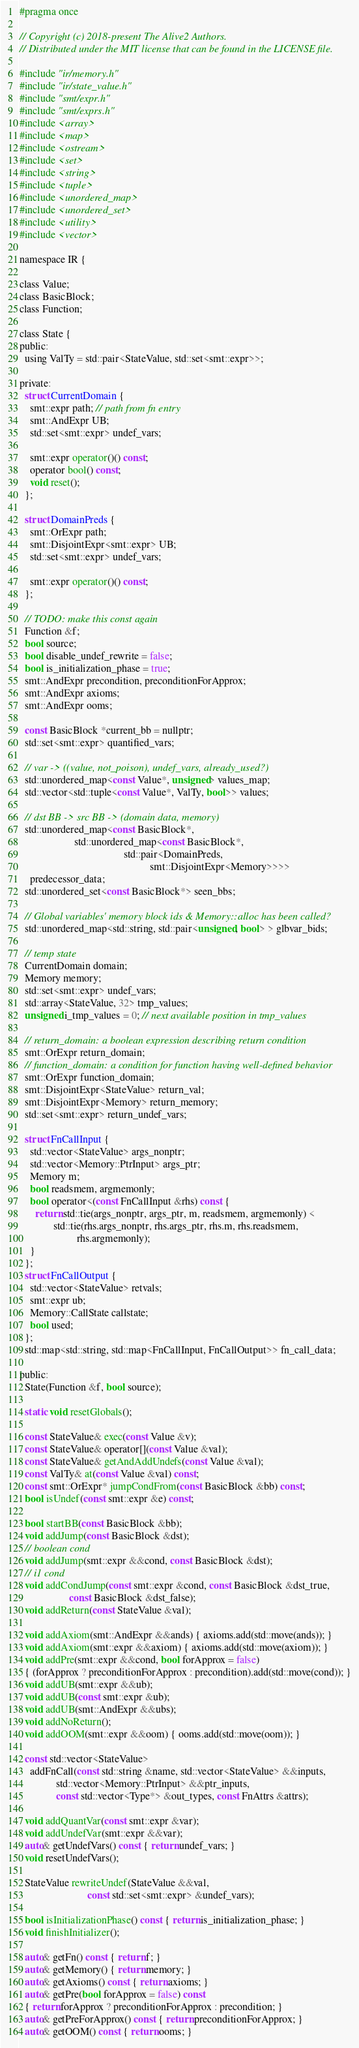Convert code to text. <code><loc_0><loc_0><loc_500><loc_500><_C_>#pragma once

// Copyright (c) 2018-present The Alive2 Authors.
// Distributed under the MIT license that can be found in the LICENSE file.

#include "ir/memory.h"
#include "ir/state_value.h"
#include "smt/expr.h"
#include "smt/exprs.h"
#include <array>
#include <map>
#include <ostream>
#include <set>
#include <string>
#include <tuple>
#include <unordered_map>
#include <unordered_set>
#include <utility>
#include <vector>

namespace IR {

class Value;
class BasicBlock;
class Function;

class State {
public:
  using ValTy = std::pair<StateValue, std::set<smt::expr>>;

private:
  struct CurrentDomain {
    smt::expr path; // path from fn entry
    smt::AndExpr UB;
    std::set<smt::expr> undef_vars;

    smt::expr operator()() const;
    operator bool() const;
    void reset();
  };

  struct DomainPreds {
    smt::OrExpr path;
    smt::DisjointExpr<smt::expr> UB;
    std::set<smt::expr> undef_vars;

    smt::expr operator()() const;
  };

  // TODO: make this const again
  Function &f;
  bool source;
  bool disable_undef_rewrite = false;
  bool is_initialization_phase = true;
  smt::AndExpr precondition, preconditionForApprox;
  smt::AndExpr axioms;
  smt::AndExpr ooms;

  const BasicBlock *current_bb = nullptr;
  std::set<smt::expr> quantified_vars;

  // var -> ((value, not_poison), undef_vars, already_used?)
  std::unordered_map<const Value*, unsigned> values_map;
  std::vector<std::tuple<const Value*, ValTy, bool>> values;

  // dst BB -> src BB -> (domain data, memory)
  std::unordered_map<const BasicBlock*,
                     std::unordered_map<const BasicBlock*,
                                        std::pair<DomainPreds,
                                                  smt::DisjointExpr<Memory>>>>
    predecessor_data;
  std::unordered_set<const BasicBlock*> seen_bbs;

  // Global variables' memory block ids & Memory::alloc has been called?
  std::unordered_map<std::string, std::pair<unsigned, bool> > glbvar_bids;

  // temp state
  CurrentDomain domain;
  Memory memory;
  std::set<smt::expr> undef_vars;
  std::array<StateValue, 32> tmp_values;
  unsigned i_tmp_values = 0; // next available position in tmp_values

  // return_domain: a boolean expression describing return condition
  smt::OrExpr return_domain;
  // function_domain: a condition for function having well-defined behavior
  smt::OrExpr function_domain;
  smt::DisjointExpr<StateValue> return_val;
  smt::DisjointExpr<Memory> return_memory;
  std::set<smt::expr> return_undef_vars;

  struct FnCallInput {
    std::vector<StateValue> args_nonptr;
    std::vector<Memory::PtrInput> args_ptr;
    Memory m;
    bool readsmem, argmemonly;
    bool operator<(const FnCallInput &rhs) const {
      return std::tie(args_nonptr, args_ptr, m, readsmem, argmemonly) <
             std::tie(rhs.args_nonptr, rhs.args_ptr, rhs.m, rhs.readsmem,
                      rhs.argmemonly);
    }
  };
  struct FnCallOutput {
    std::vector<StateValue> retvals;
    smt::expr ub;
    Memory::CallState callstate;
    bool used;
  };
  std::map<std::string, std::map<FnCallInput, FnCallOutput>> fn_call_data;

public:
  State(Function &f, bool source);

  static void resetGlobals();

  const StateValue& exec(const Value &v);
  const StateValue& operator[](const Value &val);
  const StateValue& getAndAddUndefs(const Value &val);
  const ValTy& at(const Value &val) const;
  const smt::OrExpr* jumpCondFrom(const BasicBlock &bb) const;
  bool isUndef(const smt::expr &e) const;

  bool startBB(const BasicBlock &bb);
  void addJump(const BasicBlock &dst);
  // boolean cond
  void addJump(smt::expr &&cond, const BasicBlock &dst);
  // i1 cond
  void addCondJump(const smt::expr &cond, const BasicBlock &dst_true,
                   const BasicBlock &dst_false);
  void addReturn(const StateValue &val);

  void addAxiom(smt::AndExpr &&ands) { axioms.add(std::move(ands)); }
  void addAxiom(smt::expr &&axiom) { axioms.add(std::move(axiom)); }
  void addPre(smt::expr &&cond, bool forApprox = false)
  { (forApprox ? preconditionForApprox : precondition).add(std::move(cond)); }
  void addUB(smt::expr &&ub);
  void addUB(const smt::expr &ub);
  void addUB(smt::AndExpr &&ubs);
  void addNoReturn();
  void addOOM(smt::expr &&oom) { ooms.add(std::move(oom)); }

  const std::vector<StateValue>
    addFnCall(const std::string &name, std::vector<StateValue> &&inputs,
              std::vector<Memory::PtrInput> &&ptr_inputs,
              const std::vector<Type*> &out_types, const FnAttrs &attrs);

  void addQuantVar(const smt::expr &var);
  void addUndefVar(smt::expr &&var);
  auto& getUndefVars() const { return undef_vars; }
  void resetUndefVars();

  StateValue rewriteUndef(StateValue &&val,
                          const std::set<smt::expr> &undef_vars);

  bool isInitializationPhase() const { return is_initialization_phase; }
  void finishInitializer();

  auto& getFn() const { return f; }
  auto& getMemory() { return memory; }
  auto& getAxioms() const { return axioms; }
  auto& getPre(bool forApprox = false) const
  { return forApprox ? preconditionForApprox : precondition; }
  auto& getPreForApprox() const { return preconditionForApprox; }
  auto& getOOM() const { return ooms; }</code> 